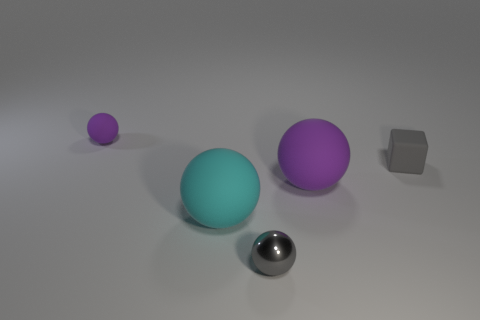Add 1 big metal blocks. How many objects exist? 6 Subtract all spheres. How many objects are left? 1 Subtract all big blue things. Subtract all big balls. How many objects are left? 3 Add 4 big cyan matte spheres. How many big cyan matte spheres are left? 5 Add 4 tiny purple rubber things. How many tiny purple rubber things exist? 5 Subtract 0 cyan blocks. How many objects are left? 5 